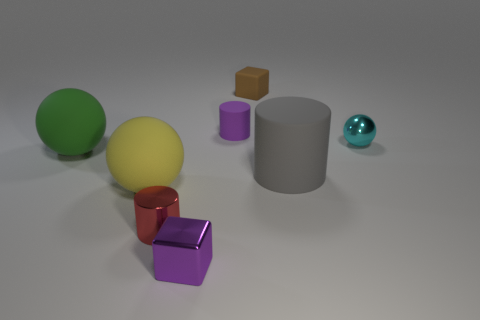There is a ball that is right of the small cube in front of the ball to the right of the brown object; what is its material?
Offer a terse response. Metal. What is the size of the yellow sphere that is made of the same material as the big gray cylinder?
Your answer should be very brief. Large. Is there anything else that is the same color as the metallic ball?
Make the answer very short. No. Do the small cylinder right of the purple metallic object and the tiny block in front of the big gray matte thing have the same color?
Provide a succinct answer. Yes. What color is the rubber cylinder on the left side of the gray cylinder?
Your answer should be very brief. Purple. Do the metallic thing in front of the red cylinder and the small matte block have the same size?
Your answer should be very brief. Yes. Is the number of gray rubber objects less than the number of small green shiny balls?
Provide a succinct answer. No. There is a tiny rubber object that is the same color as the shiny cube; what shape is it?
Give a very brief answer. Cylinder. There is a purple matte cylinder; what number of large gray cylinders are to the left of it?
Your answer should be compact. 0. Do the purple matte object and the big gray thing have the same shape?
Ensure brevity in your answer.  Yes. 